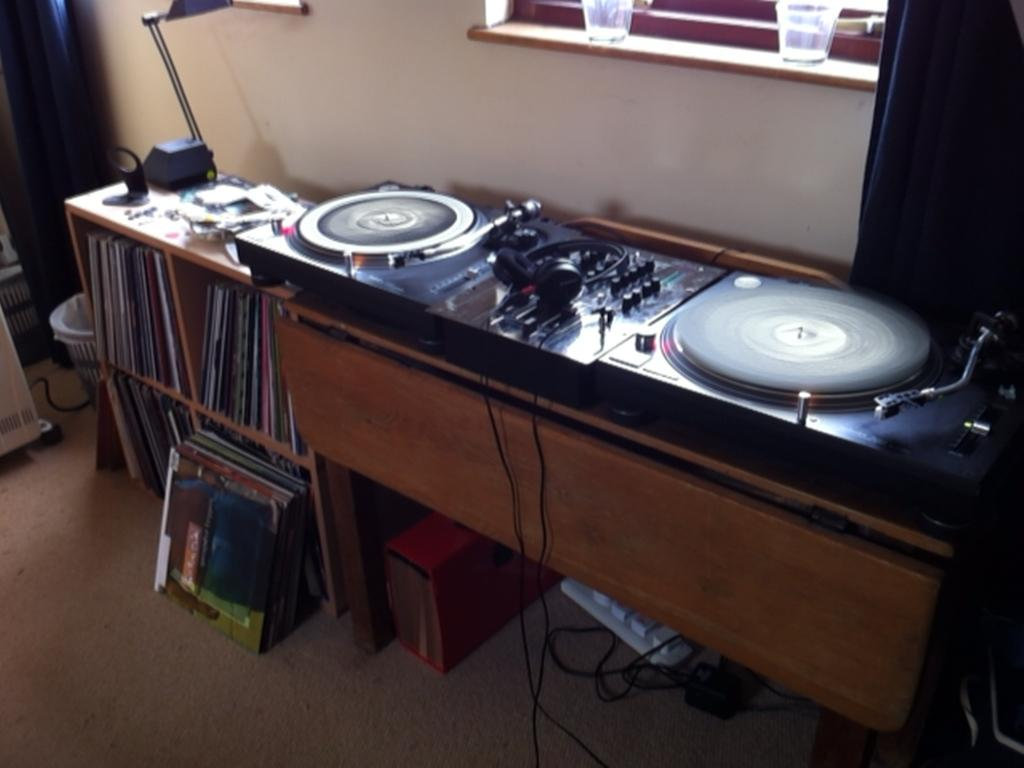What is placed on the table in the image? There is a musical system placed on a table in the image. What other furniture or storage item can be seen in the image? There is a bookshelf in the image. Where is the sofa located in the image? There is no sofa present in the image. What type of show is being performed on the musical system in the image? The image does not depict a show being performed on the musical system; it only shows the musical system placed on a table. 